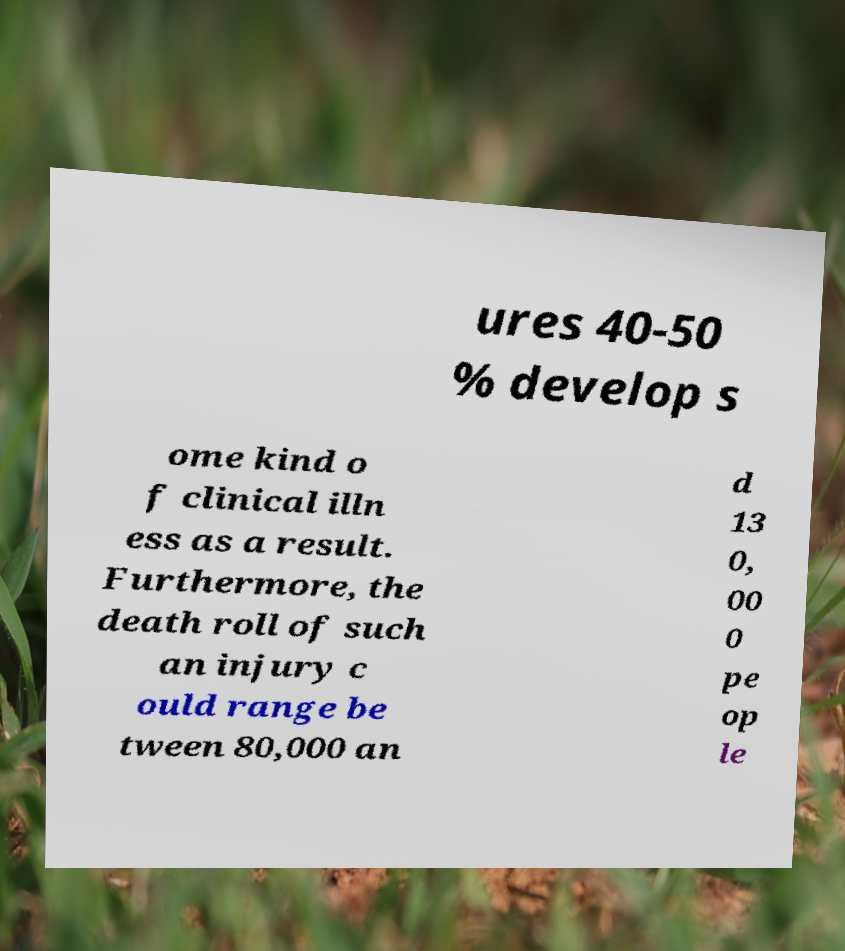I need the written content from this picture converted into text. Can you do that? ures 40-50 % develop s ome kind o f clinical illn ess as a result. Furthermore, the death roll of such an injury c ould range be tween 80,000 an d 13 0, 00 0 pe op le 